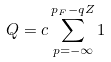<formula> <loc_0><loc_0><loc_500><loc_500>Q = c \sum _ { p = - \infty } ^ { p _ { F } - q Z } 1</formula> 